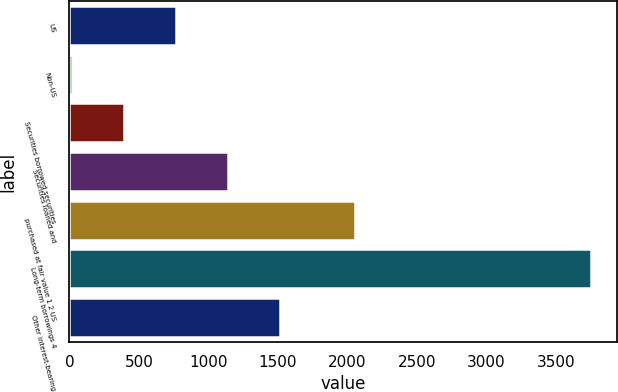Convert chart to OTSL. <chart><loc_0><loc_0><loc_500><loc_500><bar_chart><fcel>US<fcel>Non-US<fcel>Securities borrowed securities<fcel>Securities loaned and<fcel>purchased at fair value 1 2 US<fcel>Long-term borrowings 4<fcel>Other interest-bearing<nl><fcel>765.6<fcel>19<fcel>392.3<fcel>1138.9<fcel>2054<fcel>3752<fcel>1512.2<nl></chart> 